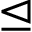Convert formula to latex. <formula><loc_0><loc_0><loc_500><loc_500>\triangleleft e q</formula> 